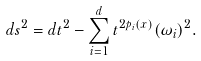Convert formula to latex. <formula><loc_0><loc_0><loc_500><loc_500>d s ^ { 2 } = d t ^ { 2 } - \sum _ { i = 1 } ^ { d } t ^ { 2 p _ { i } ( x ) } ( \omega _ { i } ) ^ { 2 } .</formula> 